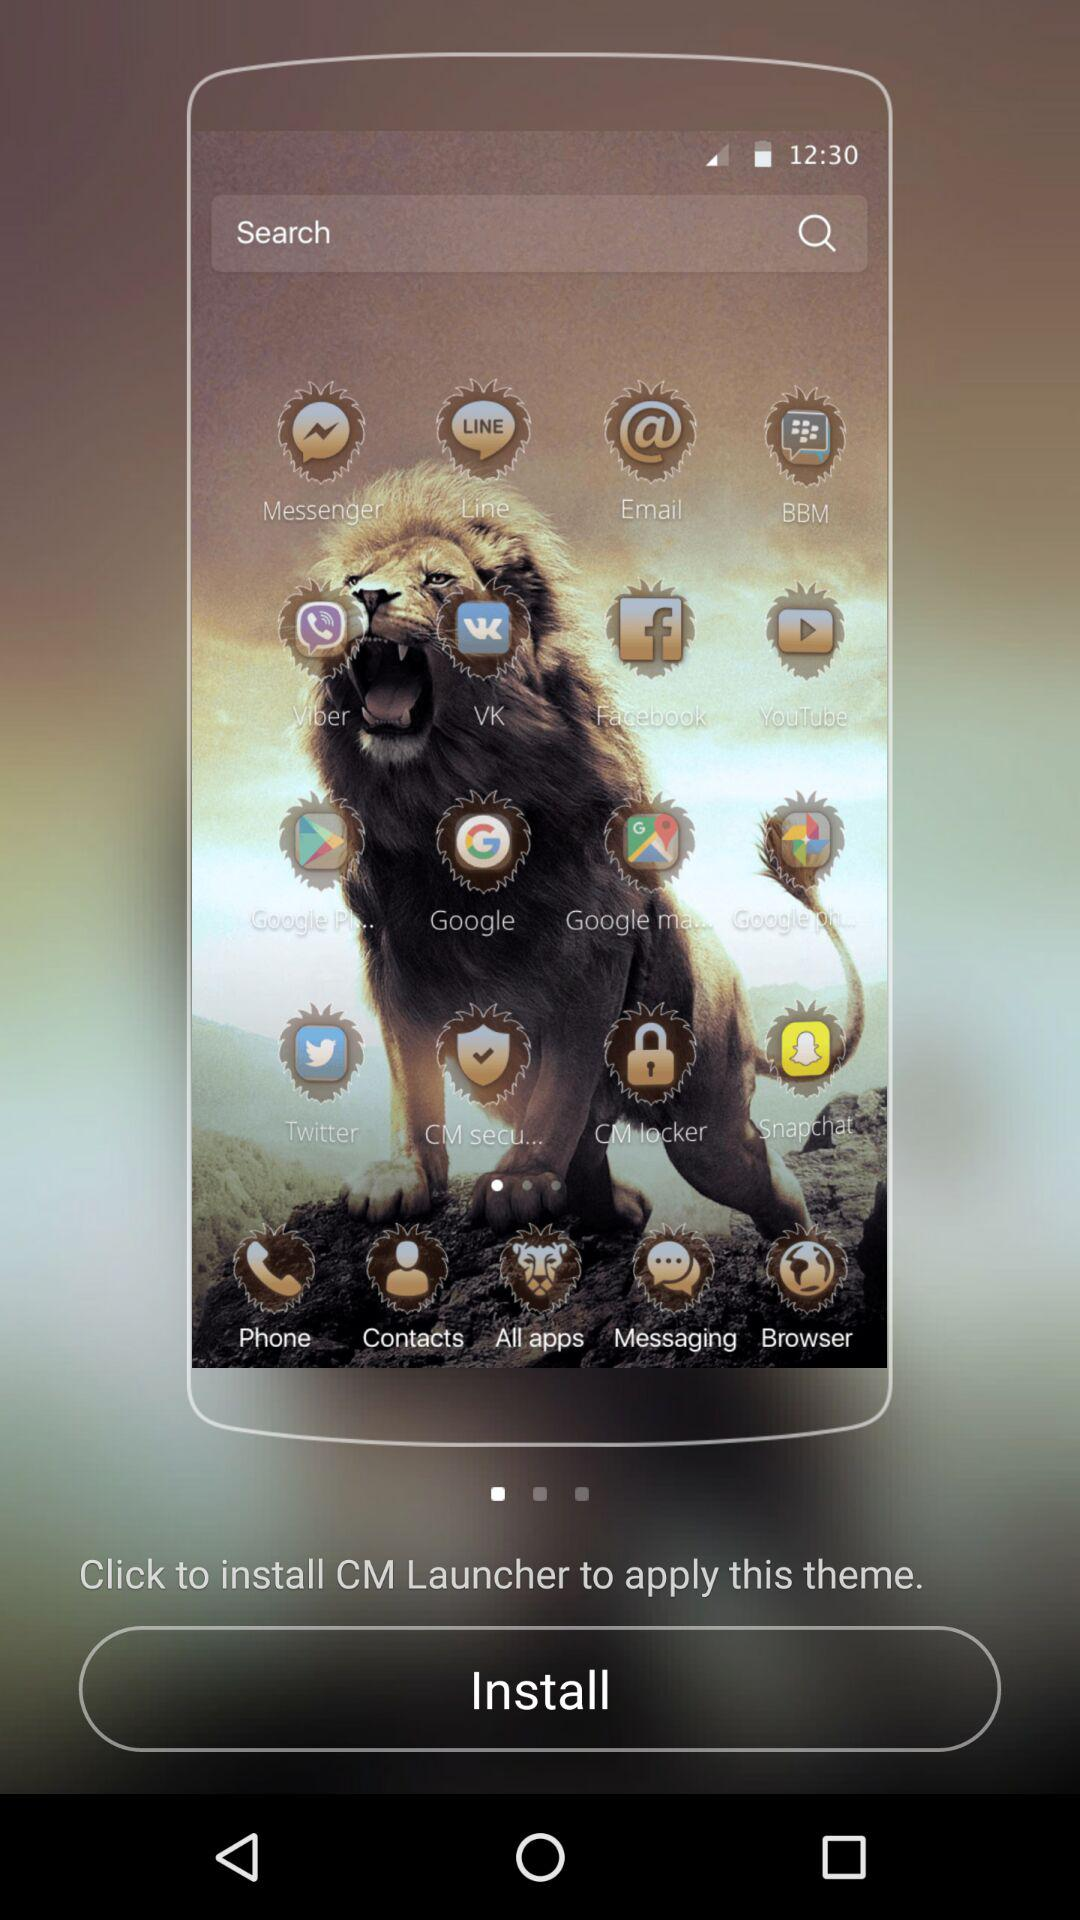What is the app for social media? The apps for social media are "Messenger", "Line", "BBM", "Viber", "VKontakte", "Facebook", "Twitter" and "Snapchat". 